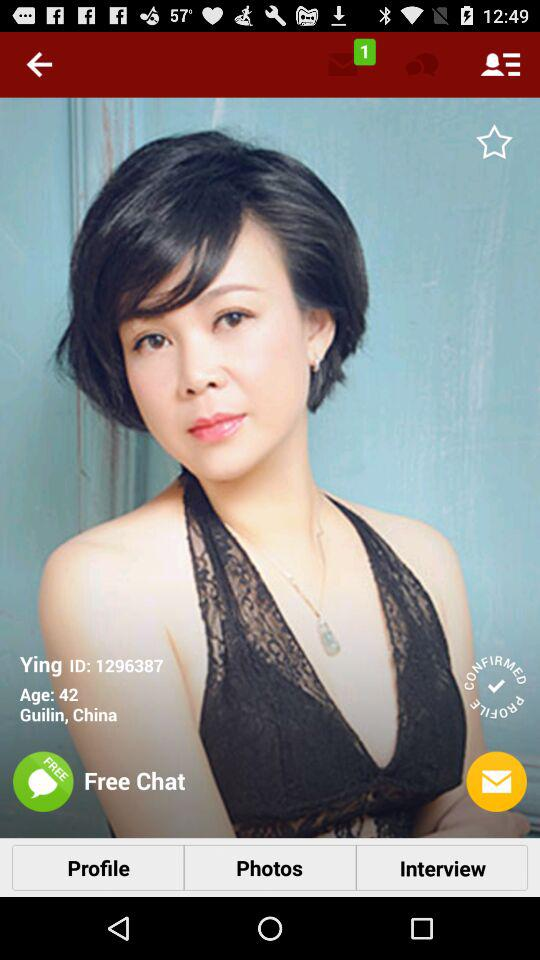What is the age? The age is 42. 